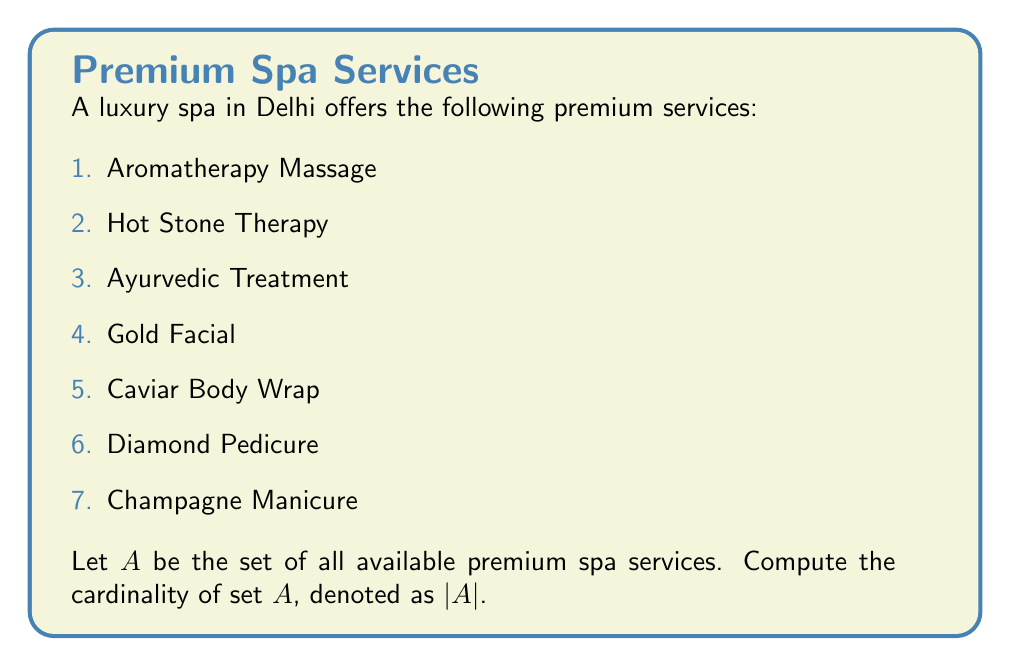Solve this math problem. To find the cardinality of set $A$, we need to count the number of distinct elements in the set. Each premium spa service listed represents a unique element in the set.

Let's count the elements:

1. Aromatherapy Massage
2. Hot Stone Therapy
3. Ayurvedic Treatment
4. Gold Facial
5. Caviar Body Wrap
6. Diamond Pedicure
7. Champagne Manicure

We can see that there are 7 distinct premium spa services in the set.

In set theory, the cardinality of a finite set is simply the number of elements in that set. Therefore, the cardinality of set $A$ is 7.

Mathematically, we express this as:

$$|A| = 7$$
Answer: $|A| = 7$ 